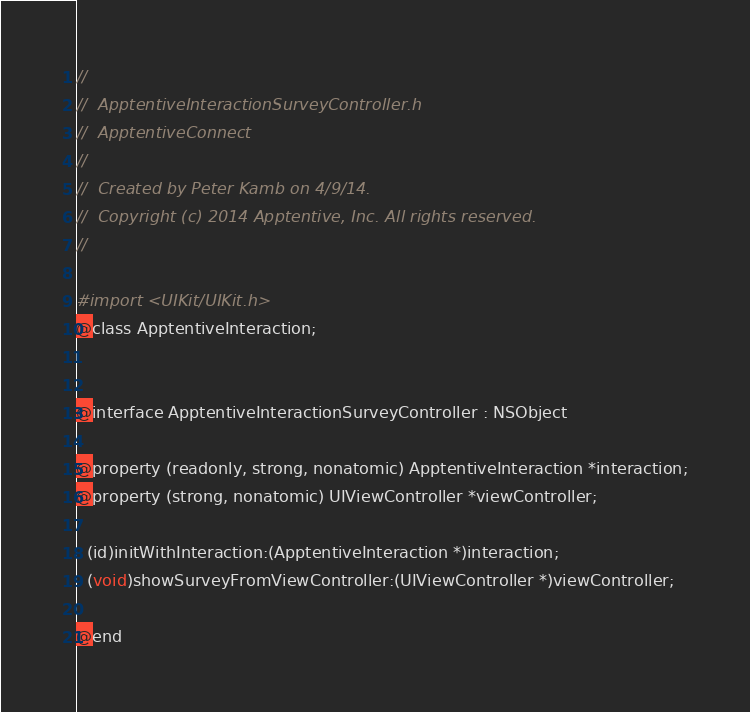Convert code to text. <code><loc_0><loc_0><loc_500><loc_500><_C_>//
//  ApptentiveInteractionSurveyController.h
//  ApptentiveConnect
//
//  Created by Peter Kamb on 4/9/14.
//  Copyright (c) 2014 Apptentive, Inc. All rights reserved.
//

#import <UIKit/UIKit.h>
@class ApptentiveInteraction;


@interface ApptentiveInteractionSurveyController : NSObject

@property (readonly, strong, nonatomic) ApptentiveInteraction *interaction;
@property (strong, nonatomic) UIViewController *viewController;

- (id)initWithInteraction:(ApptentiveInteraction *)interaction;
- (void)showSurveyFromViewController:(UIViewController *)viewController;

@end
</code> 